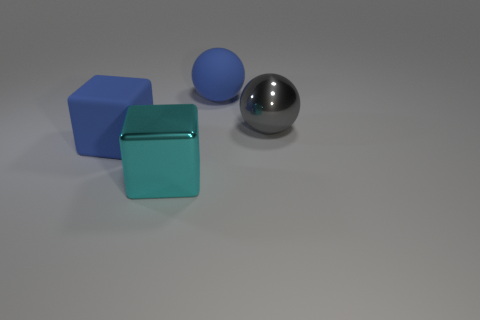Add 3 big metallic spheres. How many objects exist? 7 Subtract all red things. Subtract all large blue objects. How many objects are left? 2 Add 4 cubes. How many cubes are left? 6 Add 3 small blue rubber spheres. How many small blue rubber spheres exist? 3 Subtract 0 red blocks. How many objects are left? 4 